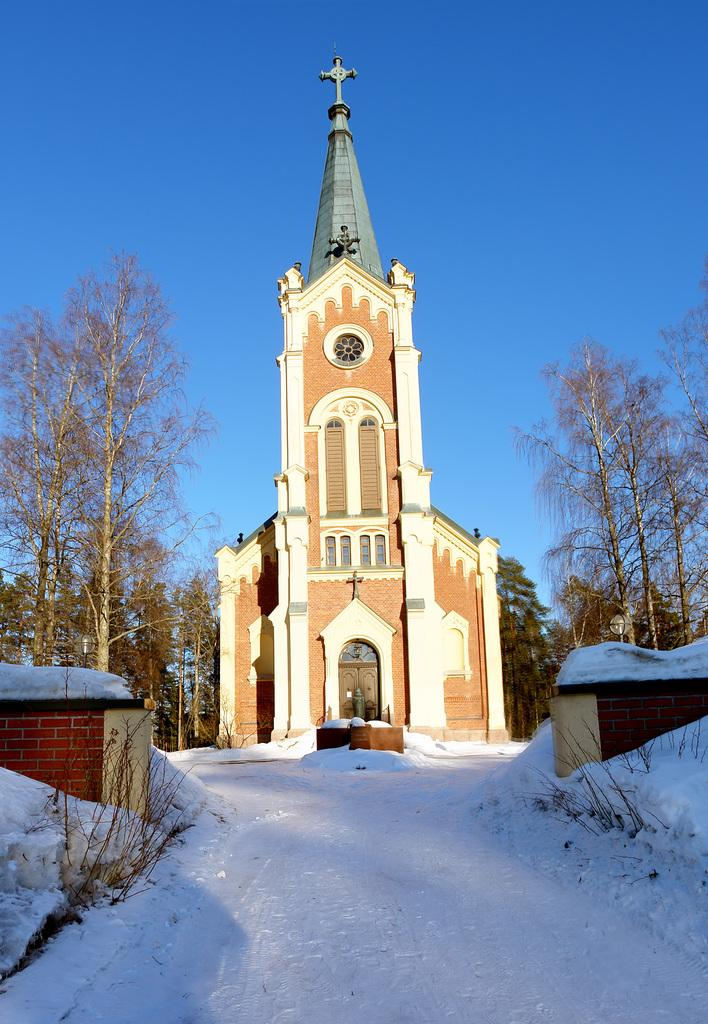What is the main structure in the foreground of the image? There is a church in the foreground of the image. What can be seen on either side of the church? Trees are on either side of the church. What type of path is visible at the bottom of the image? There is a snow path at the bottom of the image. What is visible at the top of the image? The sky is visible at the top of the image. What type of wine is being served in the church in the image? There is no wine or indication of any event involving wine in the image; it simply shows a church with trees on either side and a snow path at the bottom. 